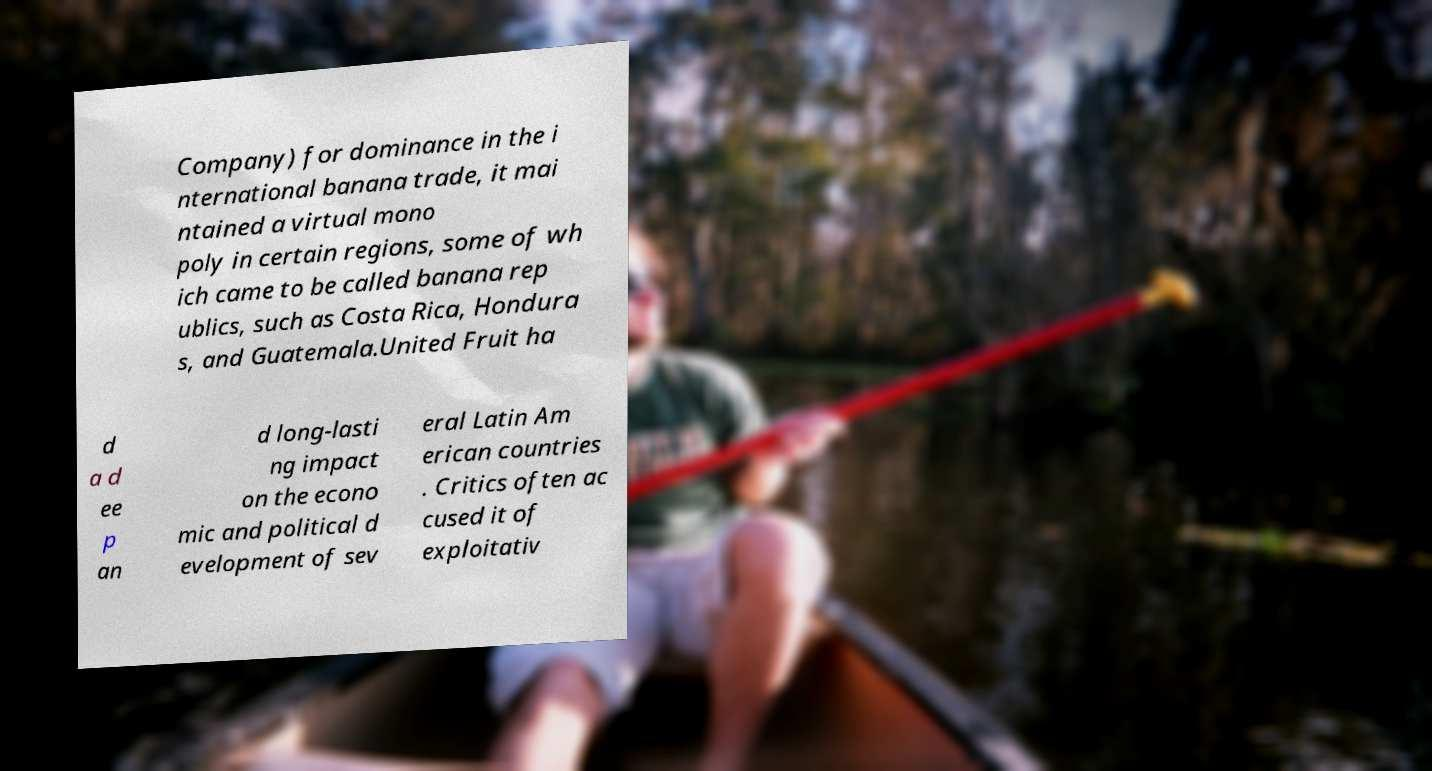I need the written content from this picture converted into text. Can you do that? Company) for dominance in the i nternational banana trade, it mai ntained a virtual mono poly in certain regions, some of wh ich came to be called banana rep ublics, such as Costa Rica, Hondura s, and Guatemala.United Fruit ha d a d ee p an d long-lasti ng impact on the econo mic and political d evelopment of sev eral Latin Am erican countries . Critics often ac cused it of exploitativ 